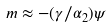<formula> <loc_0><loc_0><loc_500><loc_500>m \approx - ( \gamma / \alpha _ { 2 } ) \psi</formula> 